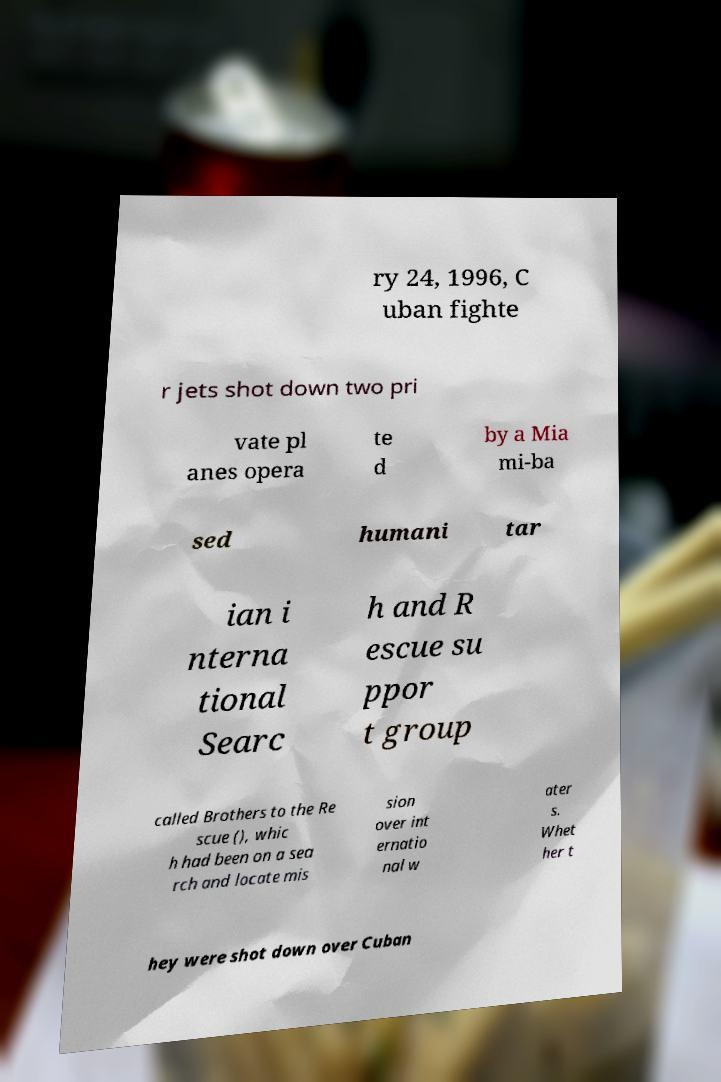There's text embedded in this image that I need extracted. Can you transcribe it verbatim? ry 24, 1996, C uban fighte r jets shot down two pri vate pl anes opera te d by a Mia mi-ba sed humani tar ian i nterna tional Searc h and R escue su ppor t group called Brothers to the Re scue (), whic h had been on a sea rch and locate mis sion over int ernatio nal w ater s. Whet her t hey were shot down over Cuban 